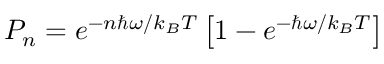<formula> <loc_0><loc_0><loc_500><loc_500>P _ { n } = e ^ { - n \hbar { \omega } / k _ { B } T } \left [ 1 - e ^ { - \hbar { \omega } / k _ { B } T } \right ]</formula> 